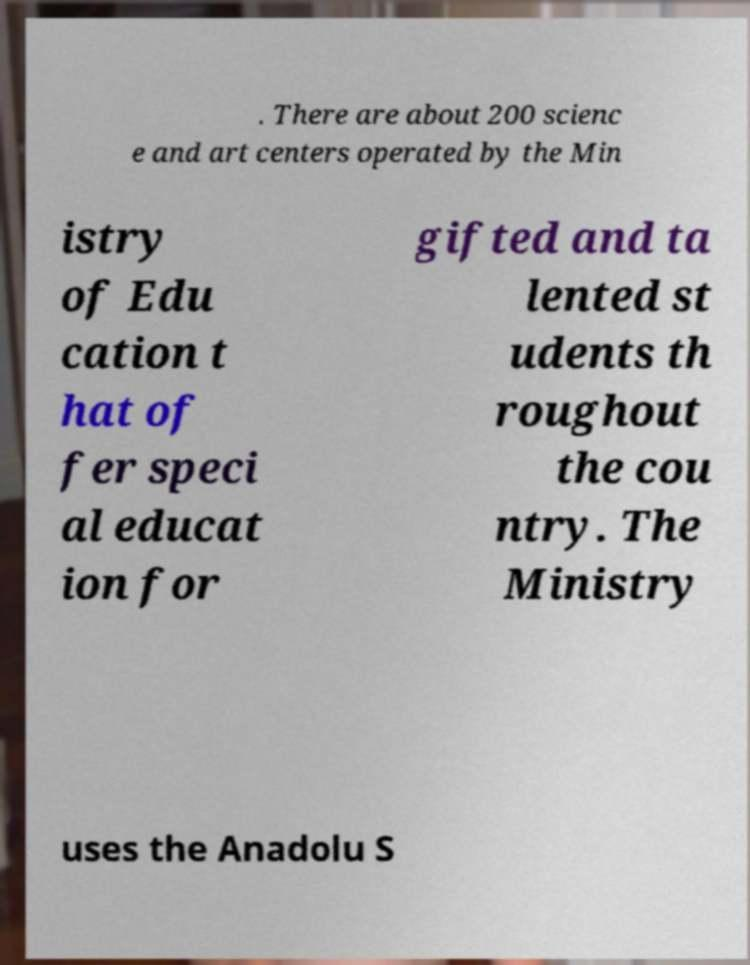I need the written content from this picture converted into text. Can you do that? . There are about 200 scienc e and art centers operated by the Min istry of Edu cation t hat of fer speci al educat ion for gifted and ta lented st udents th roughout the cou ntry. The Ministry uses the Anadolu S 